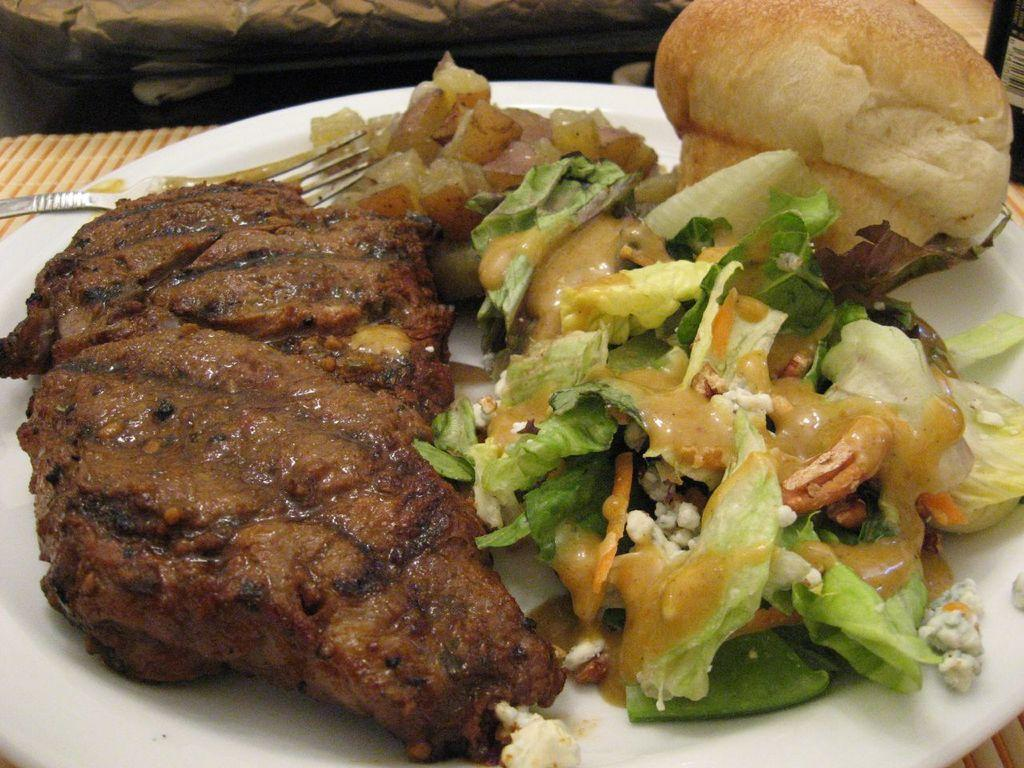What color is the plate that is visible in the image? There is a white color plate in the image. What utensil is placed on the plate? There is a fork on the plate. What is on the plate besides the fork? There is a food item on the plate. What type of seat is visible in the image? There is no seat present in the image. What position is the stove in the image? There is no stove present in the image. 